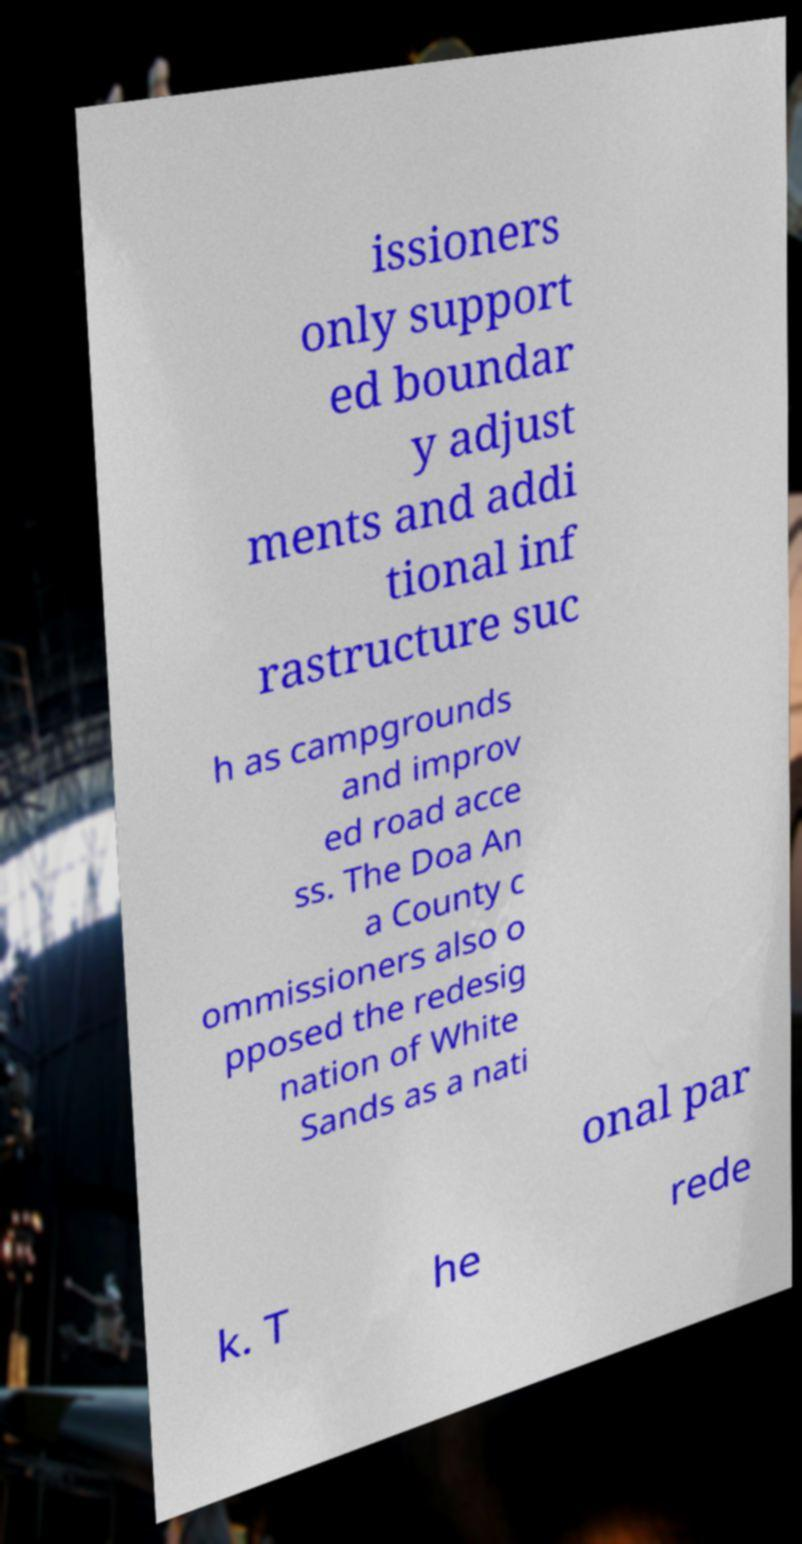For documentation purposes, I need the text within this image transcribed. Could you provide that? issioners only support ed boundar y adjust ments and addi tional inf rastructure suc h as campgrounds and improv ed road acce ss. The Doa An a County c ommissioners also o pposed the redesig nation of White Sands as a nati onal par k. T he rede 